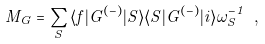Convert formula to latex. <formula><loc_0><loc_0><loc_500><loc_500>M _ { G } = \sum _ { S } { \langle f | G ^ { ( - ) } | S \rangle \langle S | G ^ { ( - ) } | i \rangle } { \omega _ { S } ^ { - 1 } } \ ,</formula> 